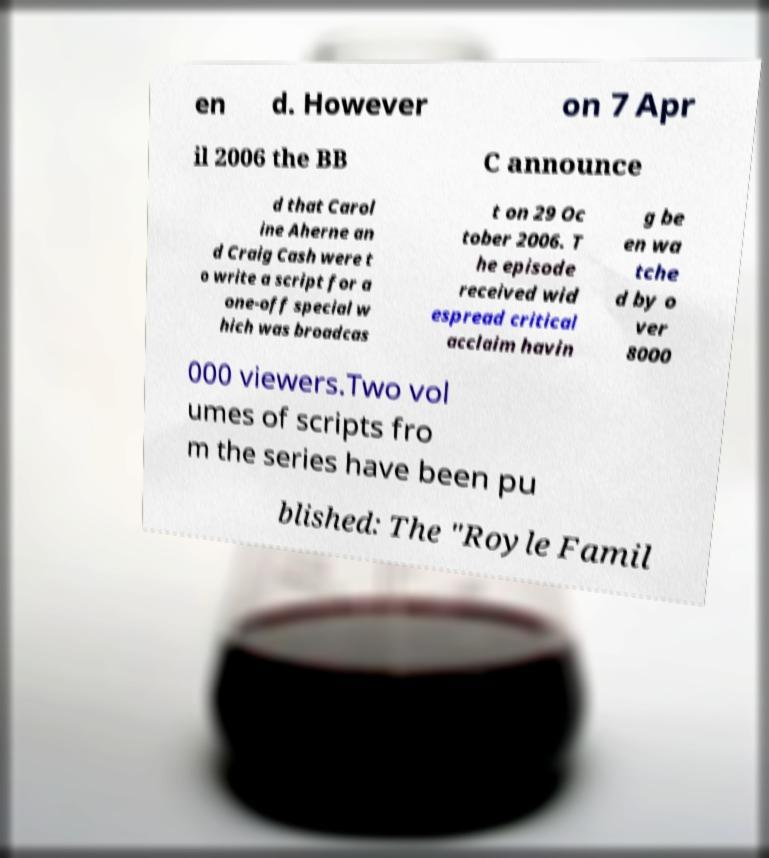I need the written content from this picture converted into text. Can you do that? en d. However on 7 Apr il 2006 the BB C announce d that Carol ine Aherne an d Craig Cash were t o write a script for a one-off special w hich was broadcas t on 29 Oc tober 2006. T he episode received wid espread critical acclaim havin g be en wa tche d by o ver 8000 000 viewers.Two vol umes of scripts fro m the series have been pu blished: The "Royle Famil 